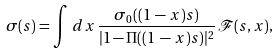<formula> <loc_0><loc_0><loc_500><loc_500>\sigma ( s ) = \int \, d x \, \frac { \sigma _ { 0 } ( ( 1 \, - \, x ) s ) } { | 1 - \Pi ( ( 1 \, - \, x ) s ) | ^ { 2 } } \, \mathcal { F } ( s , x ) ,</formula> 